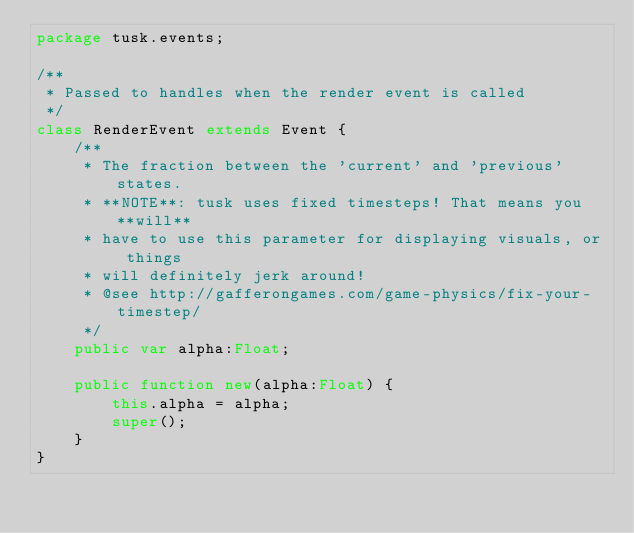Convert code to text. <code><loc_0><loc_0><loc_500><loc_500><_Haxe_>package tusk.events;

/**
 * Passed to handles when the render event is called
 */
class RenderEvent extends Event {
	/**
	 * The fraction between the 'current' and 'previous' states.
	 * **NOTE**: tusk uses fixed timesteps! That means you **will**
	 * have to use this parameter for displaying visuals, or things
	 * will definitely jerk around!
	 * @see http://gafferongames.com/game-physics/fix-your-timestep/
	 */
	public var alpha:Float;

	public function new(alpha:Float) {
		this.alpha = alpha;
		super();
	}
}</code> 